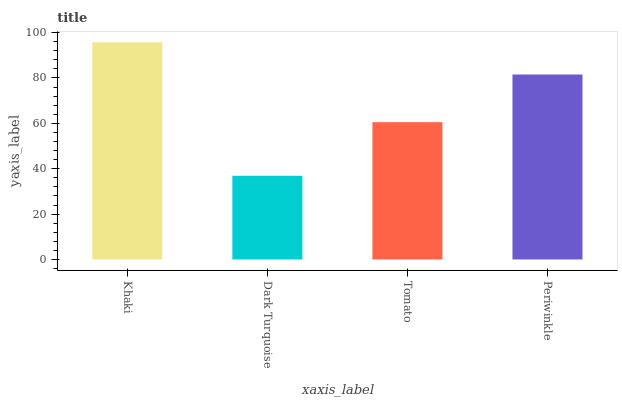Is Tomato the minimum?
Answer yes or no. No. Is Tomato the maximum?
Answer yes or no. No. Is Tomato greater than Dark Turquoise?
Answer yes or no. Yes. Is Dark Turquoise less than Tomato?
Answer yes or no. Yes. Is Dark Turquoise greater than Tomato?
Answer yes or no. No. Is Tomato less than Dark Turquoise?
Answer yes or no. No. Is Periwinkle the high median?
Answer yes or no. Yes. Is Tomato the low median?
Answer yes or no. Yes. Is Dark Turquoise the high median?
Answer yes or no. No. Is Khaki the low median?
Answer yes or no. No. 